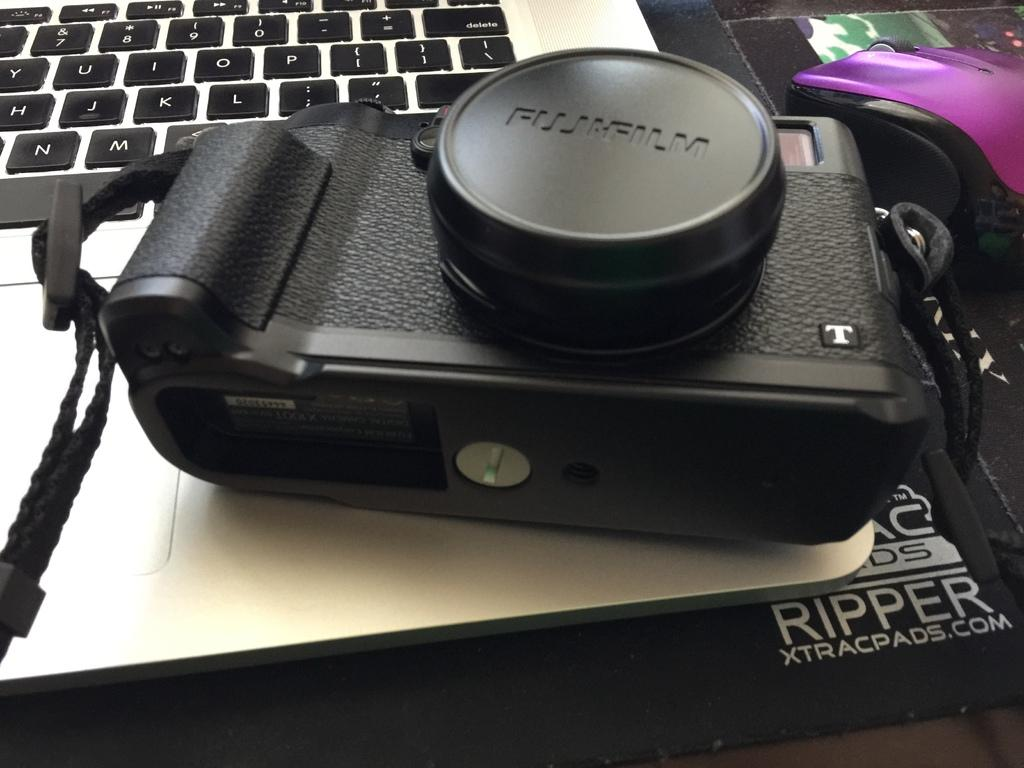What device is present on the laptop in the image? There is a camera present on the laptop. What is another input device that can be seen beside the laptop? There is a mouse beside the laptop. Where is the drawer located in the image? There is no drawer present in the image. What type of fuel is being used by the camera on the laptop? The camera on the laptop does not use fuel; it is powered by the laptop's battery or power source. 